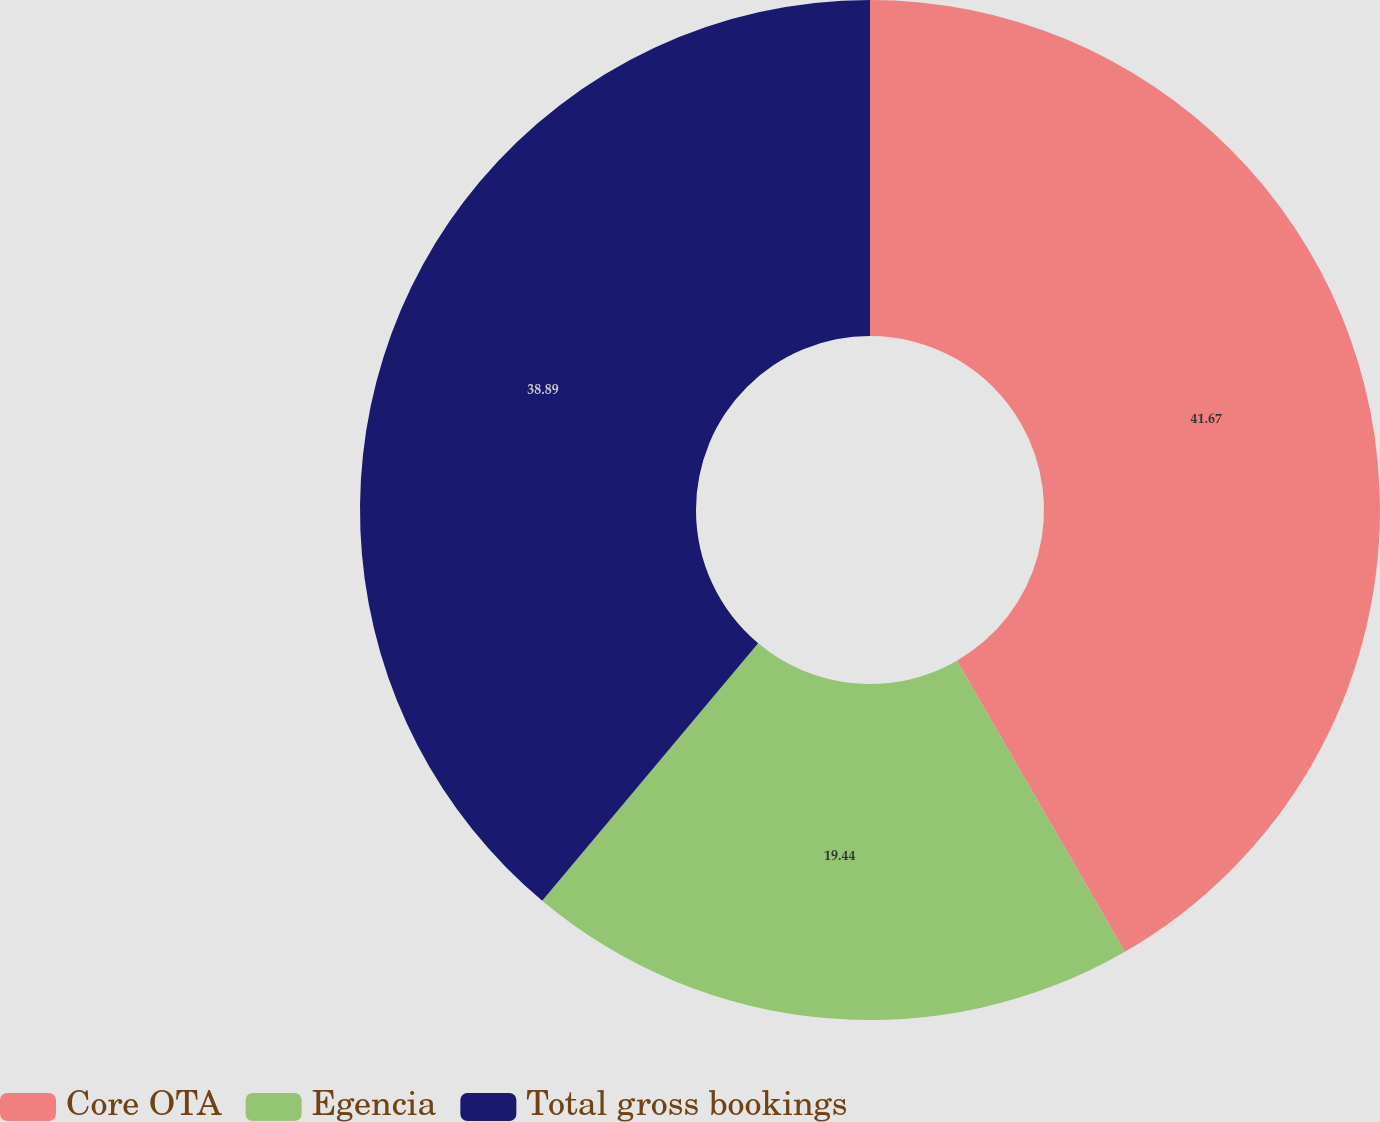<chart> <loc_0><loc_0><loc_500><loc_500><pie_chart><fcel>Core OTA<fcel>Egencia<fcel>Total gross bookings<nl><fcel>41.67%<fcel>19.44%<fcel>38.89%<nl></chart> 